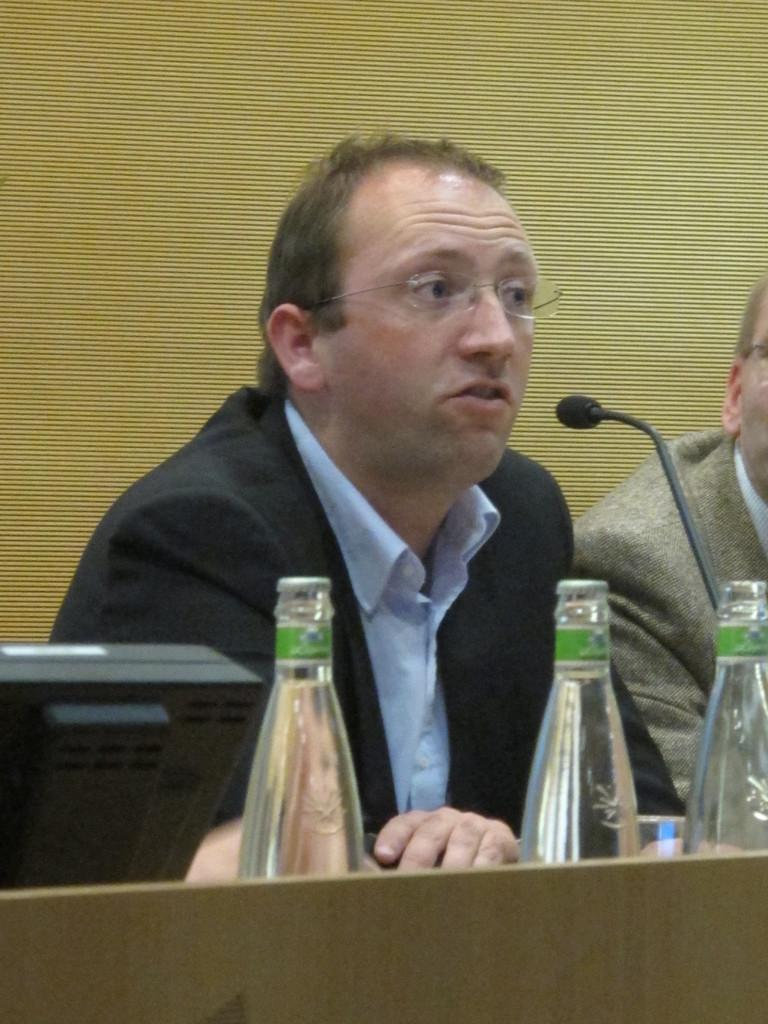How many people are seated in the image? There are two men seated in the image. What object is present that is typically used for amplifying sound? There is a microphone in the image. How many bottles can be seen in the image? There are three bottles in the image. What is on the table in the image? There is a monitor on the table in the image. What is one of the men doing in the image? One of the men is speaking using the microphone. What type of level can be seen in the image? There is no level present in the image. Is there a cemetery visible in the background of the image? There is no cemetery present in the image. 